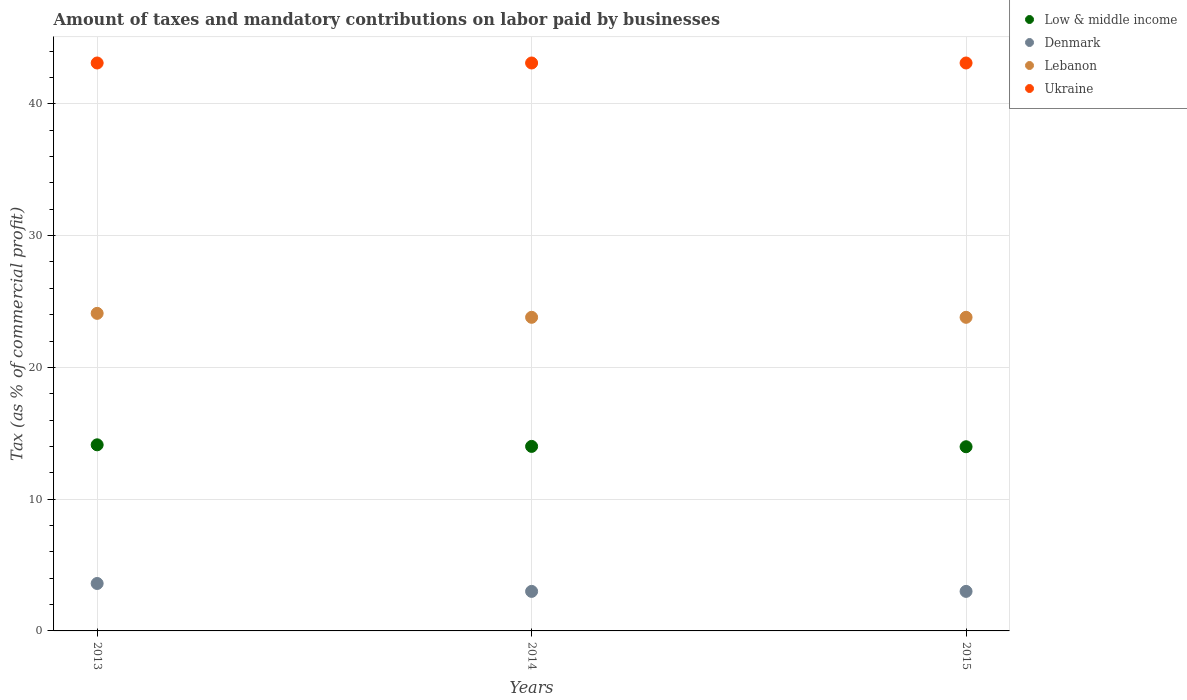Is the number of dotlines equal to the number of legend labels?
Your answer should be very brief. Yes. What is the percentage of taxes paid by businesses in Denmark in 2014?
Provide a short and direct response. 3. Across all years, what is the maximum percentage of taxes paid by businesses in Lebanon?
Ensure brevity in your answer.  24.1. In which year was the percentage of taxes paid by businesses in Ukraine maximum?
Keep it short and to the point. 2013. In which year was the percentage of taxes paid by businesses in Low & middle income minimum?
Make the answer very short. 2015. What is the total percentage of taxes paid by businesses in Low & middle income in the graph?
Provide a short and direct response. 42.1. What is the difference between the percentage of taxes paid by businesses in Low & middle income in 2014 and that in 2015?
Keep it short and to the point. 0.03. What is the average percentage of taxes paid by businesses in Lebanon per year?
Offer a very short reply. 23.9. In the year 2013, what is the difference between the percentage of taxes paid by businesses in Ukraine and percentage of taxes paid by businesses in Lebanon?
Offer a very short reply. 19. What is the ratio of the percentage of taxes paid by businesses in Lebanon in 2013 to that in 2015?
Ensure brevity in your answer.  1.01. Is the percentage of taxes paid by businesses in Ukraine in 2013 less than that in 2014?
Your response must be concise. No. Is the difference between the percentage of taxes paid by businesses in Ukraine in 2014 and 2015 greater than the difference between the percentage of taxes paid by businesses in Lebanon in 2014 and 2015?
Your answer should be very brief. No. What is the difference between the highest and the second highest percentage of taxes paid by businesses in Denmark?
Provide a succinct answer. 0.6. In how many years, is the percentage of taxes paid by businesses in Low & middle income greater than the average percentage of taxes paid by businesses in Low & middle income taken over all years?
Give a very brief answer. 1. Is it the case that in every year, the sum of the percentage of taxes paid by businesses in Denmark and percentage of taxes paid by businesses in Ukraine  is greater than the sum of percentage of taxes paid by businesses in Lebanon and percentage of taxes paid by businesses in Low & middle income?
Provide a succinct answer. No. Is it the case that in every year, the sum of the percentage of taxes paid by businesses in Low & middle income and percentage of taxes paid by businesses in Ukraine  is greater than the percentage of taxes paid by businesses in Lebanon?
Make the answer very short. Yes. Is the percentage of taxes paid by businesses in Lebanon strictly less than the percentage of taxes paid by businesses in Denmark over the years?
Your answer should be compact. No. How many dotlines are there?
Provide a short and direct response. 4. How many years are there in the graph?
Your answer should be compact. 3. What is the difference between two consecutive major ticks on the Y-axis?
Your answer should be compact. 10. Are the values on the major ticks of Y-axis written in scientific E-notation?
Your response must be concise. No. Does the graph contain grids?
Keep it short and to the point. Yes. How many legend labels are there?
Your answer should be compact. 4. What is the title of the graph?
Offer a terse response. Amount of taxes and mandatory contributions on labor paid by businesses. Does "Mauritania" appear as one of the legend labels in the graph?
Provide a succinct answer. No. What is the label or title of the Y-axis?
Your answer should be very brief. Tax (as % of commercial profit). What is the Tax (as % of commercial profit) of Low & middle income in 2013?
Your answer should be compact. 14.12. What is the Tax (as % of commercial profit) in Denmark in 2013?
Your response must be concise. 3.6. What is the Tax (as % of commercial profit) in Lebanon in 2013?
Your answer should be very brief. 24.1. What is the Tax (as % of commercial profit) in Ukraine in 2013?
Your response must be concise. 43.1. What is the Tax (as % of commercial profit) of Low & middle income in 2014?
Keep it short and to the point. 14. What is the Tax (as % of commercial profit) in Lebanon in 2014?
Provide a succinct answer. 23.8. What is the Tax (as % of commercial profit) in Ukraine in 2014?
Your answer should be compact. 43.1. What is the Tax (as % of commercial profit) of Low & middle income in 2015?
Give a very brief answer. 13.98. What is the Tax (as % of commercial profit) of Denmark in 2015?
Make the answer very short. 3. What is the Tax (as % of commercial profit) of Lebanon in 2015?
Your answer should be compact. 23.8. What is the Tax (as % of commercial profit) in Ukraine in 2015?
Offer a very short reply. 43.1. Across all years, what is the maximum Tax (as % of commercial profit) of Low & middle income?
Keep it short and to the point. 14.12. Across all years, what is the maximum Tax (as % of commercial profit) of Lebanon?
Make the answer very short. 24.1. Across all years, what is the maximum Tax (as % of commercial profit) of Ukraine?
Provide a short and direct response. 43.1. Across all years, what is the minimum Tax (as % of commercial profit) in Low & middle income?
Make the answer very short. 13.98. Across all years, what is the minimum Tax (as % of commercial profit) of Denmark?
Offer a terse response. 3. Across all years, what is the minimum Tax (as % of commercial profit) in Lebanon?
Ensure brevity in your answer.  23.8. Across all years, what is the minimum Tax (as % of commercial profit) in Ukraine?
Make the answer very short. 43.1. What is the total Tax (as % of commercial profit) of Low & middle income in the graph?
Your response must be concise. 42.1. What is the total Tax (as % of commercial profit) of Denmark in the graph?
Offer a very short reply. 9.6. What is the total Tax (as % of commercial profit) of Lebanon in the graph?
Ensure brevity in your answer.  71.7. What is the total Tax (as % of commercial profit) of Ukraine in the graph?
Your answer should be compact. 129.3. What is the difference between the Tax (as % of commercial profit) of Low & middle income in 2013 and that in 2014?
Offer a very short reply. 0.12. What is the difference between the Tax (as % of commercial profit) of Lebanon in 2013 and that in 2014?
Offer a very short reply. 0.3. What is the difference between the Tax (as % of commercial profit) in Ukraine in 2013 and that in 2014?
Your answer should be very brief. 0. What is the difference between the Tax (as % of commercial profit) of Low & middle income in 2013 and that in 2015?
Offer a very short reply. 0.15. What is the difference between the Tax (as % of commercial profit) of Denmark in 2013 and that in 2015?
Make the answer very short. 0.6. What is the difference between the Tax (as % of commercial profit) in Ukraine in 2013 and that in 2015?
Your answer should be very brief. 0. What is the difference between the Tax (as % of commercial profit) in Low & middle income in 2014 and that in 2015?
Make the answer very short. 0.03. What is the difference between the Tax (as % of commercial profit) in Lebanon in 2014 and that in 2015?
Offer a very short reply. 0. What is the difference between the Tax (as % of commercial profit) in Ukraine in 2014 and that in 2015?
Provide a succinct answer. 0. What is the difference between the Tax (as % of commercial profit) in Low & middle income in 2013 and the Tax (as % of commercial profit) in Denmark in 2014?
Your response must be concise. 11.12. What is the difference between the Tax (as % of commercial profit) of Low & middle income in 2013 and the Tax (as % of commercial profit) of Lebanon in 2014?
Ensure brevity in your answer.  -9.68. What is the difference between the Tax (as % of commercial profit) in Low & middle income in 2013 and the Tax (as % of commercial profit) in Ukraine in 2014?
Provide a succinct answer. -28.98. What is the difference between the Tax (as % of commercial profit) in Denmark in 2013 and the Tax (as % of commercial profit) in Lebanon in 2014?
Keep it short and to the point. -20.2. What is the difference between the Tax (as % of commercial profit) in Denmark in 2013 and the Tax (as % of commercial profit) in Ukraine in 2014?
Keep it short and to the point. -39.5. What is the difference between the Tax (as % of commercial profit) in Lebanon in 2013 and the Tax (as % of commercial profit) in Ukraine in 2014?
Your answer should be compact. -19. What is the difference between the Tax (as % of commercial profit) of Low & middle income in 2013 and the Tax (as % of commercial profit) of Denmark in 2015?
Give a very brief answer. 11.12. What is the difference between the Tax (as % of commercial profit) of Low & middle income in 2013 and the Tax (as % of commercial profit) of Lebanon in 2015?
Provide a succinct answer. -9.68. What is the difference between the Tax (as % of commercial profit) in Low & middle income in 2013 and the Tax (as % of commercial profit) in Ukraine in 2015?
Ensure brevity in your answer.  -28.98. What is the difference between the Tax (as % of commercial profit) in Denmark in 2013 and the Tax (as % of commercial profit) in Lebanon in 2015?
Keep it short and to the point. -20.2. What is the difference between the Tax (as % of commercial profit) in Denmark in 2013 and the Tax (as % of commercial profit) in Ukraine in 2015?
Your response must be concise. -39.5. What is the difference between the Tax (as % of commercial profit) of Lebanon in 2013 and the Tax (as % of commercial profit) of Ukraine in 2015?
Provide a succinct answer. -19. What is the difference between the Tax (as % of commercial profit) of Low & middle income in 2014 and the Tax (as % of commercial profit) of Denmark in 2015?
Your response must be concise. 11. What is the difference between the Tax (as % of commercial profit) in Low & middle income in 2014 and the Tax (as % of commercial profit) in Lebanon in 2015?
Ensure brevity in your answer.  -9.8. What is the difference between the Tax (as % of commercial profit) of Low & middle income in 2014 and the Tax (as % of commercial profit) of Ukraine in 2015?
Your answer should be very brief. -29.1. What is the difference between the Tax (as % of commercial profit) in Denmark in 2014 and the Tax (as % of commercial profit) in Lebanon in 2015?
Offer a terse response. -20.8. What is the difference between the Tax (as % of commercial profit) in Denmark in 2014 and the Tax (as % of commercial profit) in Ukraine in 2015?
Your response must be concise. -40.1. What is the difference between the Tax (as % of commercial profit) of Lebanon in 2014 and the Tax (as % of commercial profit) of Ukraine in 2015?
Ensure brevity in your answer.  -19.3. What is the average Tax (as % of commercial profit) in Low & middle income per year?
Provide a succinct answer. 14.03. What is the average Tax (as % of commercial profit) of Denmark per year?
Your answer should be compact. 3.2. What is the average Tax (as % of commercial profit) in Lebanon per year?
Provide a short and direct response. 23.9. What is the average Tax (as % of commercial profit) of Ukraine per year?
Your answer should be very brief. 43.1. In the year 2013, what is the difference between the Tax (as % of commercial profit) of Low & middle income and Tax (as % of commercial profit) of Denmark?
Your response must be concise. 10.52. In the year 2013, what is the difference between the Tax (as % of commercial profit) in Low & middle income and Tax (as % of commercial profit) in Lebanon?
Offer a very short reply. -9.98. In the year 2013, what is the difference between the Tax (as % of commercial profit) in Low & middle income and Tax (as % of commercial profit) in Ukraine?
Your answer should be very brief. -28.98. In the year 2013, what is the difference between the Tax (as % of commercial profit) in Denmark and Tax (as % of commercial profit) in Lebanon?
Offer a terse response. -20.5. In the year 2013, what is the difference between the Tax (as % of commercial profit) in Denmark and Tax (as % of commercial profit) in Ukraine?
Give a very brief answer. -39.5. In the year 2014, what is the difference between the Tax (as % of commercial profit) of Low & middle income and Tax (as % of commercial profit) of Denmark?
Ensure brevity in your answer.  11. In the year 2014, what is the difference between the Tax (as % of commercial profit) in Low & middle income and Tax (as % of commercial profit) in Lebanon?
Provide a succinct answer. -9.8. In the year 2014, what is the difference between the Tax (as % of commercial profit) of Low & middle income and Tax (as % of commercial profit) of Ukraine?
Give a very brief answer. -29.1. In the year 2014, what is the difference between the Tax (as % of commercial profit) of Denmark and Tax (as % of commercial profit) of Lebanon?
Ensure brevity in your answer.  -20.8. In the year 2014, what is the difference between the Tax (as % of commercial profit) in Denmark and Tax (as % of commercial profit) in Ukraine?
Keep it short and to the point. -40.1. In the year 2014, what is the difference between the Tax (as % of commercial profit) of Lebanon and Tax (as % of commercial profit) of Ukraine?
Ensure brevity in your answer.  -19.3. In the year 2015, what is the difference between the Tax (as % of commercial profit) of Low & middle income and Tax (as % of commercial profit) of Denmark?
Make the answer very short. 10.98. In the year 2015, what is the difference between the Tax (as % of commercial profit) in Low & middle income and Tax (as % of commercial profit) in Lebanon?
Offer a very short reply. -9.82. In the year 2015, what is the difference between the Tax (as % of commercial profit) in Low & middle income and Tax (as % of commercial profit) in Ukraine?
Your response must be concise. -29.12. In the year 2015, what is the difference between the Tax (as % of commercial profit) of Denmark and Tax (as % of commercial profit) of Lebanon?
Make the answer very short. -20.8. In the year 2015, what is the difference between the Tax (as % of commercial profit) in Denmark and Tax (as % of commercial profit) in Ukraine?
Offer a terse response. -40.1. In the year 2015, what is the difference between the Tax (as % of commercial profit) in Lebanon and Tax (as % of commercial profit) in Ukraine?
Your answer should be compact. -19.3. What is the ratio of the Tax (as % of commercial profit) in Low & middle income in 2013 to that in 2014?
Provide a succinct answer. 1.01. What is the ratio of the Tax (as % of commercial profit) of Lebanon in 2013 to that in 2014?
Your answer should be very brief. 1.01. What is the ratio of the Tax (as % of commercial profit) of Low & middle income in 2013 to that in 2015?
Your response must be concise. 1.01. What is the ratio of the Tax (as % of commercial profit) of Lebanon in 2013 to that in 2015?
Ensure brevity in your answer.  1.01. What is the ratio of the Tax (as % of commercial profit) in Low & middle income in 2014 to that in 2015?
Offer a terse response. 1. What is the ratio of the Tax (as % of commercial profit) in Ukraine in 2014 to that in 2015?
Provide a succinct answer. 1. What is the difference between the highest and the second highest Tax (as % of commercial profit) of Low & middle income?
Offer a terse response. 0.12. What is the difference between the highest and the second highest Tax (as % of commercial profit) of Denmark?
Ensure brevity in your answer.  0.6. What is the difference between the highest and the lowest Tax (as % of commercial profit) of Low & middle income?
Ensure brevity in your answer.  0.15. What is the difference between the highest and the lowest Tax (as % of commercial profit) in Denmark?
Offer a terse response. 0.6. What is the difference between the highest and the lowest Tax (as % of commercial profit) in Ukraine?
Make the answer very short. 0. 